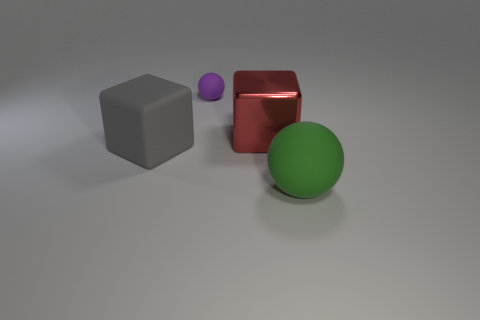Add 3 brown rubber blocks. How many objects exist? 7 Subtract all purple things. Subtract all big blue metal objects. How many objects are left? 3 Add 4 tiny balls. How many tiny balls are left? 5 Add 3 big rubber objects. How many big rubber objects exist? 5 Subtract 0 green cubes. How many objects are left? 4 